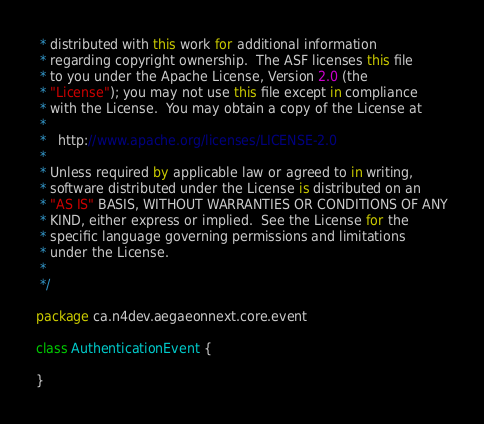<code> <loc_0><loc_0><loc_500><loc_500><_Kotlin_> * distributed with this work for additional information
 * regarding copyright ownership.  The ASF licenses this file
 * to you under the Apache License, Version 2.0 (the
 * "License"); you may not use this file except in compliance
 * with the License.  You may obtain a copy of the License at
 *
 *   http://www.apache.org/licenses/LICENSE-2.0
 *
 * Unless required by applicable law or agreed to in writing,
 * software distributed under the License is distributed on an
 * "AS IS" BASIS, WITHOUT WARRANTIES OR CONDITIONS OF ANY
 * KIND, either express or implied.  See the License for the
 * specific language governing permissions and limitations
 * under the License.
 *
 */

package ca.n4dev.aegaeonnext.core.event

class AuthenticationEvent {

}
</code> 